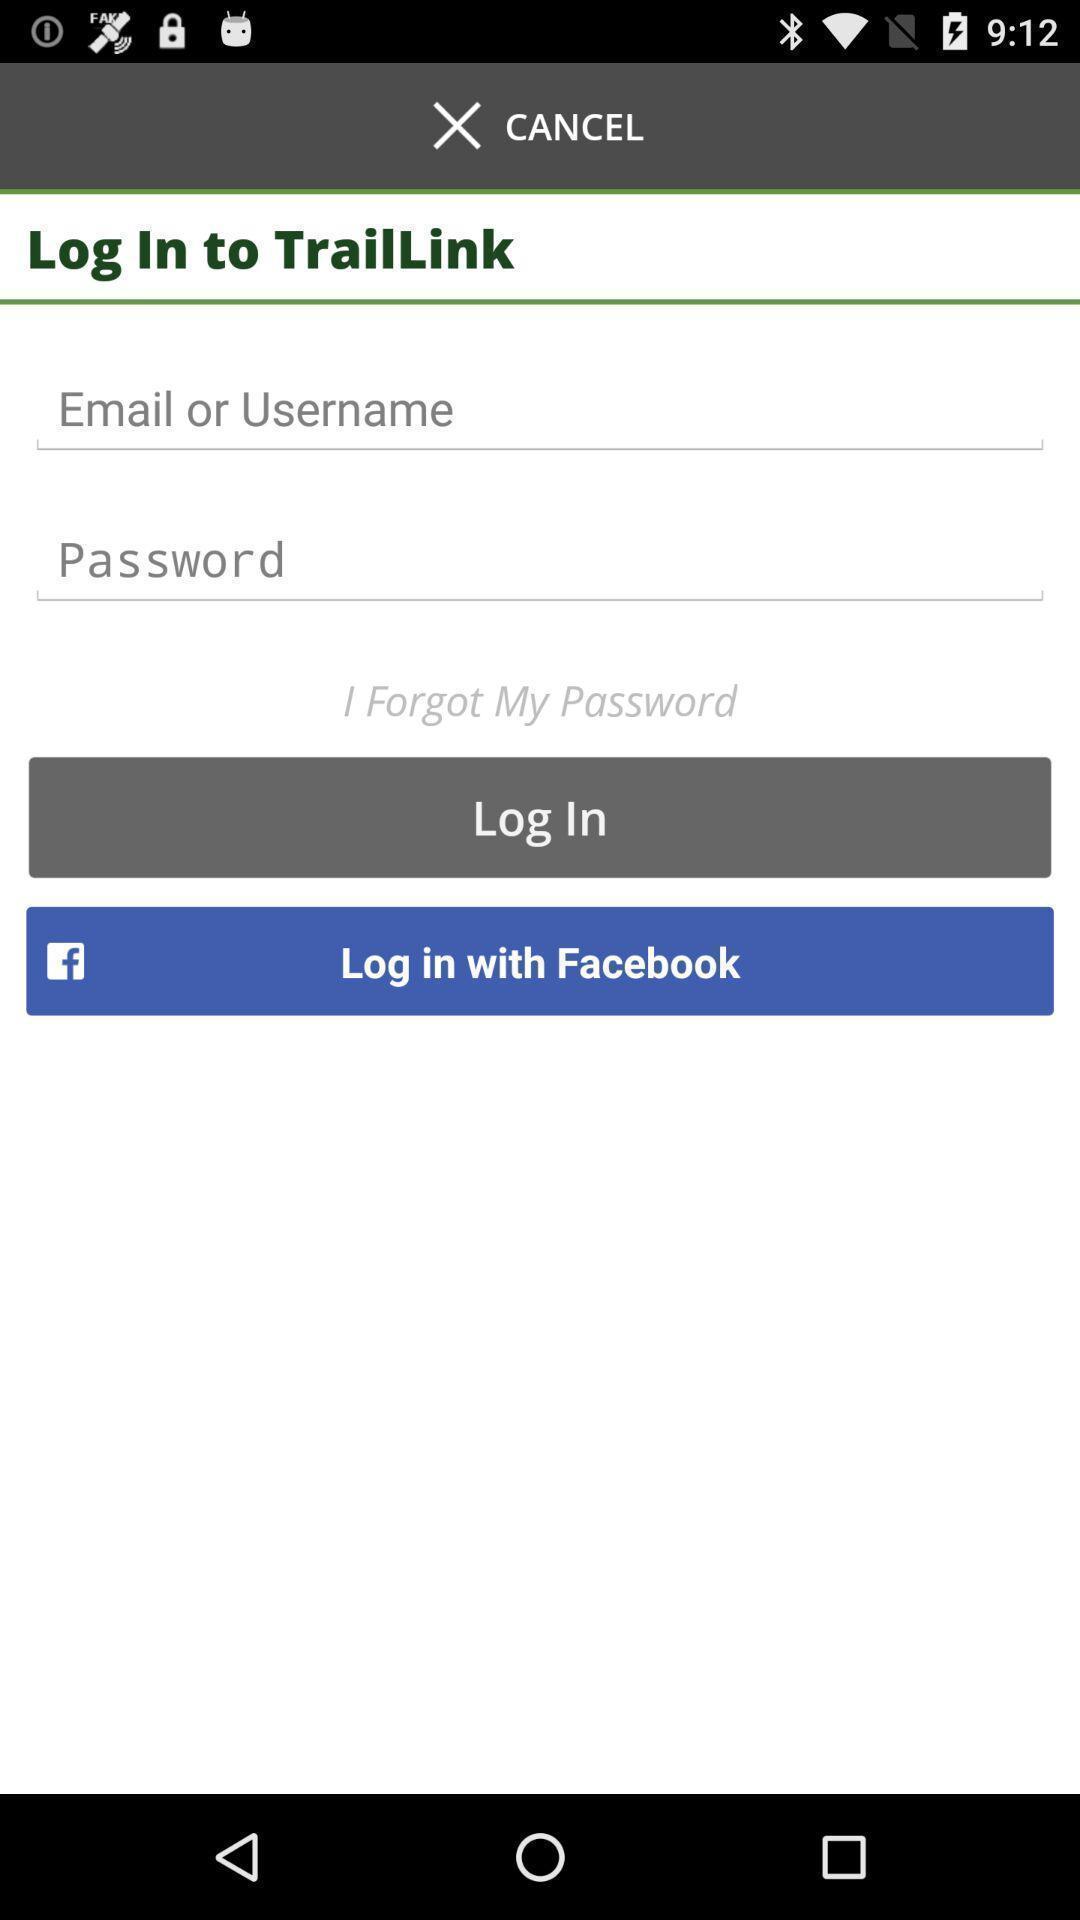Describe the key features of this screenshot. Login page. 